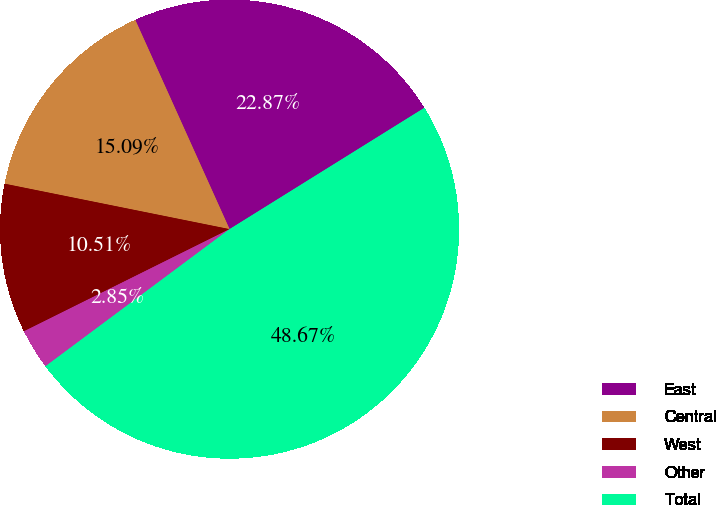Convert chart to OTSL. <chart><loc_0><loc_0><loc_500><loc_500><pie_chart><fcel>East<fcel>Central<fcel>West<fcel>Other<fcel>Total<nl><fcel>22.87%<fcel>15.09%<fcel>10.51%<fcel>2.85%<fcel>48.67%<nl></chart> 